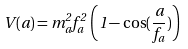Convert formula to latex. <formula><loc_0><loc_0><loc_500><loc_500>V ( a ) = m ^ { 2 } _ { a } f ^ { 2 } _ { a } \, \left ( 1 - \cos ( \frac { a } { f _ { a } } ) \right )</formula> 